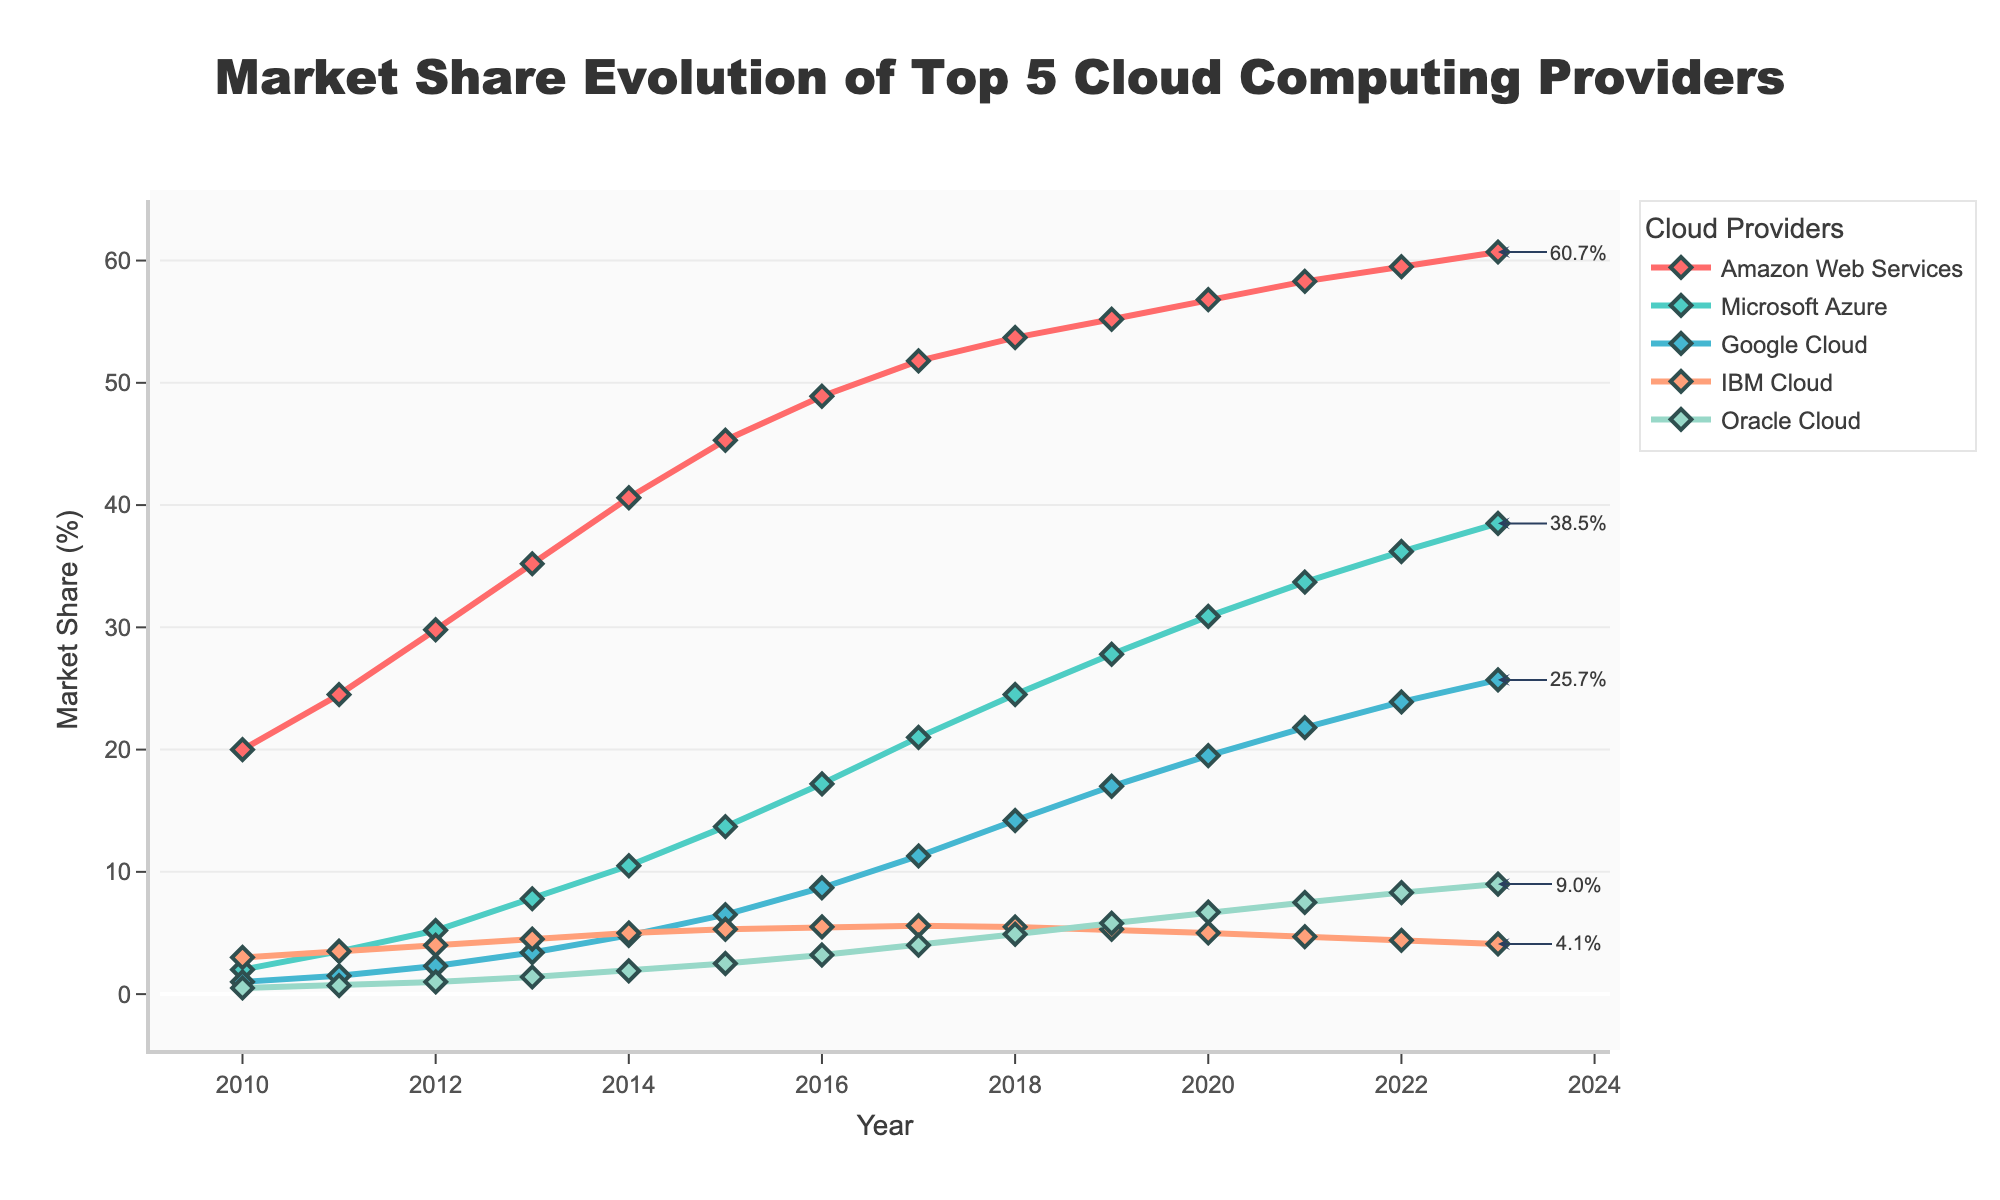Which cloud provider had the highest market share in 2023? By checking the plot, it's clear that the line representing Amazon Web Services (AWS) is the highest at the year 2023.
Answer: Amazon Web Services How did the market share of Oracle Cloud change from 2010 to 2023? The market share for Oracle Cloud started at 0.5% in 2010 and increased to 9.0% in 2023.
Answer: Increased from 0.5% to 9.0% Which cloud provider showed the most significant growth between 2010 and 2023? By comparing the starting and ending points of each provider's line, Amazon Web Services (AWS) grew from 20.0% to 60.7%, which is an increase of 40.7%, the largest among all.
Answer: Amazon Web Services What is the combined market share of Google Cloud and Microsoft Azure in 2023? In 2023, Google Cloud had 25.7% and Microsoft Azure had 38.5%. Adding them gives 25.7 + 38.5 = 64.2%.
Answer: 64.2% By how much did IBM Cloud's market share decline from 2014 to 2023? Observing the plot, IBM Cloud's market share was 5.0% in 2014 and declined to 4.1% in 2023. The difference is 5.0% - 4.1% = 0.9%.
Answer: 0.9% Which two cloud providers had the closest market share values in 2020? Referring to the chart, IBM Cloud had 5.0% and Oracle Cloud had 6.7% in 2020. The difference between them is 6.7% - 5.0% = 1.7%, the smallest difference between any two providers in that year.
Answer: IBM Cloud and Oracle Cloud On average, how much did Amazon Web Services' market share increase per year from 2010 to 2023? The difference in AWS market share between 2023 and 2010 is 60.7% - 20.0% = 40.7%. Dividing this by the number of years (2023 - 2010 = 13) gives the average annual increase: 40.7% / 13 ≈ 3.13%.
Answer: 3.13% Which cloud provider had a steady market share of around 5% from 2016 to 2023? Reviewing the plot, IBM Cloud had market shares around 5% from 2016 to 2023.
Answer: IBM Cloud When did Google Cloud surpass a market share of 10%? Google Cloud's market share first surpassed 10% in the year 2017 as depicted in the plot.
Answer: 2017 